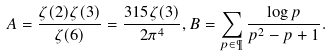<formula> <loc_0><loc_0><loc_500><loc_500>A = \frac { \zeta ( 2 ) \zeta ( 3 ) } { \zeta ( 6 ) } = \frac { 3 1 5 \zeta ( 3 ) } { 2 \pi ^ { 4 } } , B = \sum _ { p \in \P } \frac { \log p } { p ^ { 2 } - p + 1 } .</formula> 